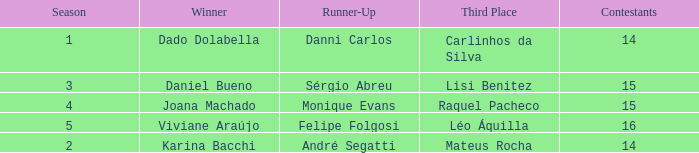In what season did Raquel Pacheco finish in third place? 4.0. 